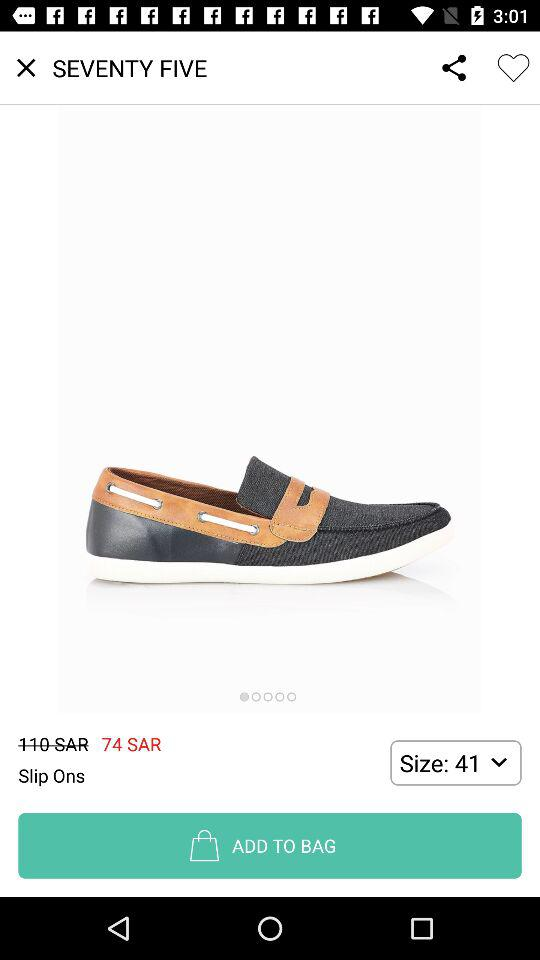What is the size of the shoe?
Answer the question using a single word or phrase. 41 